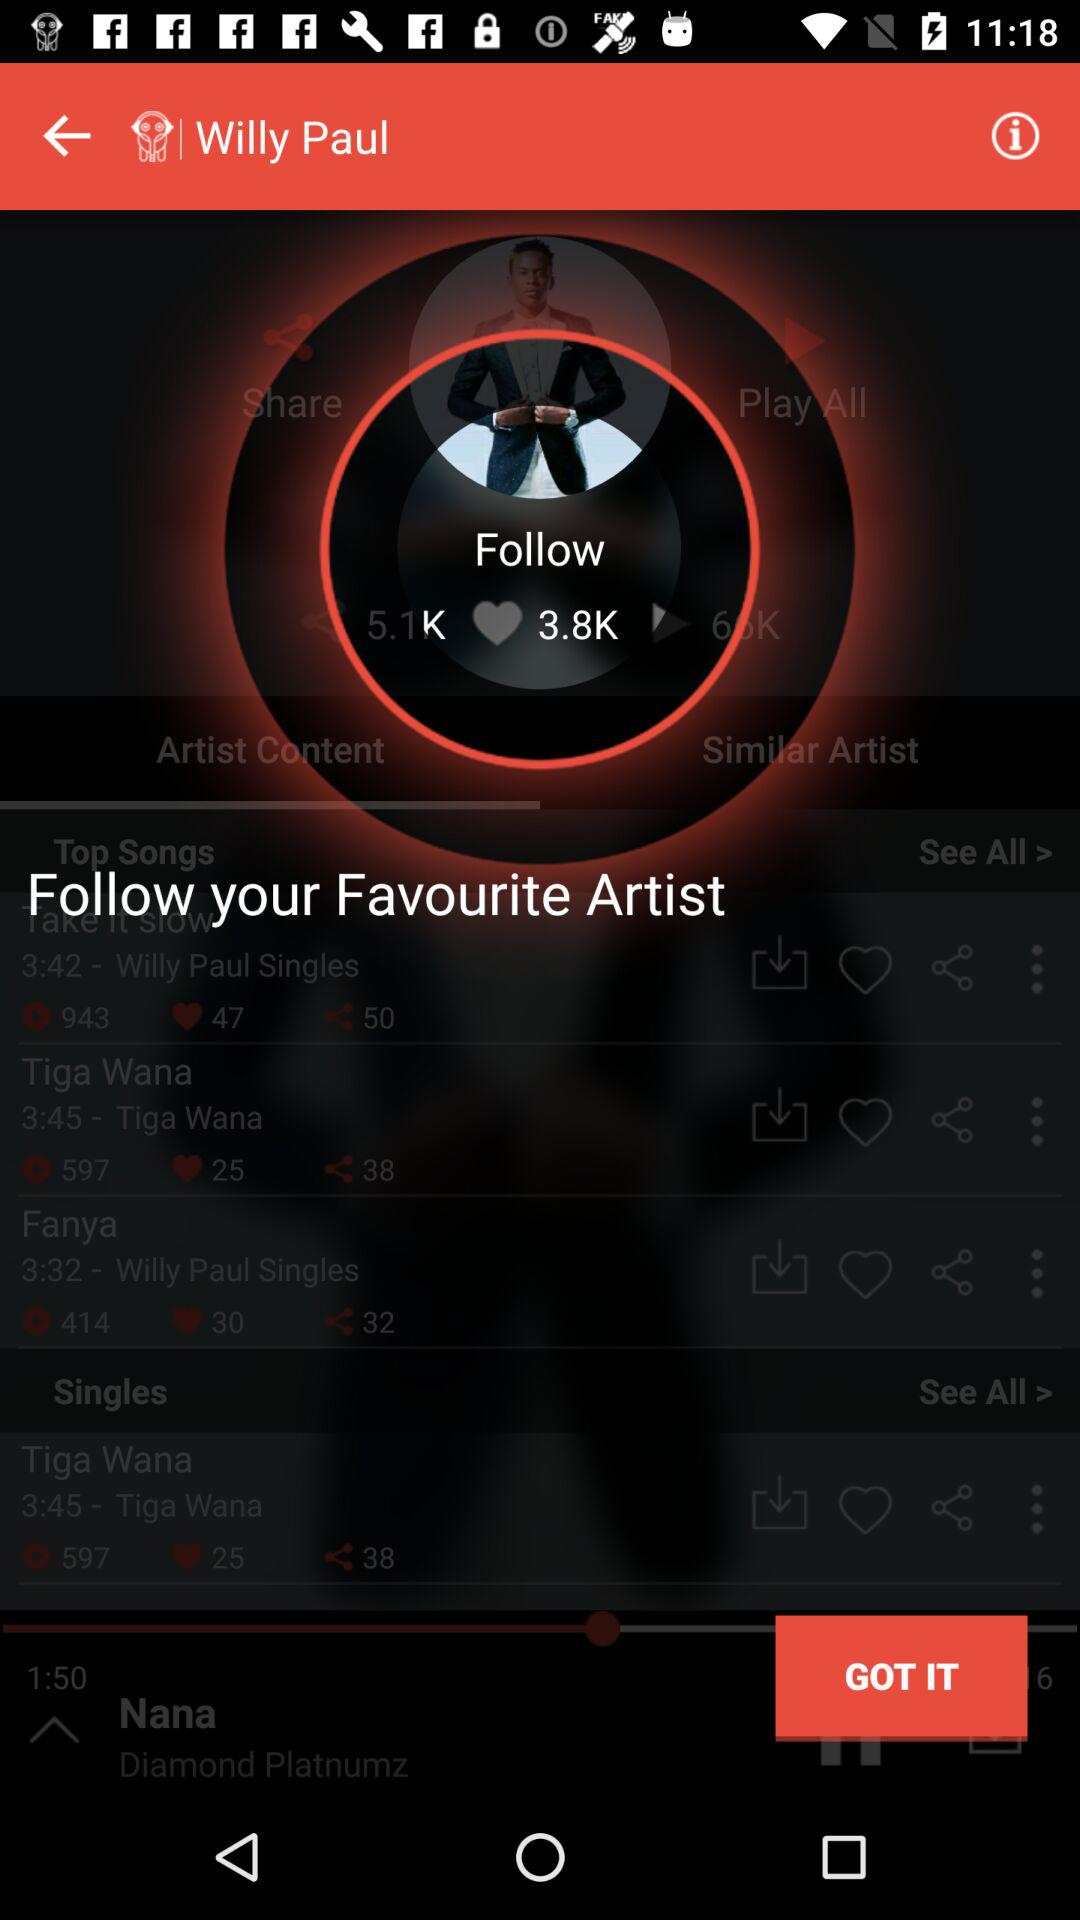Who is the artist of the song "Fanya"? The artist of the song "Fanya" is Willy Paul. 